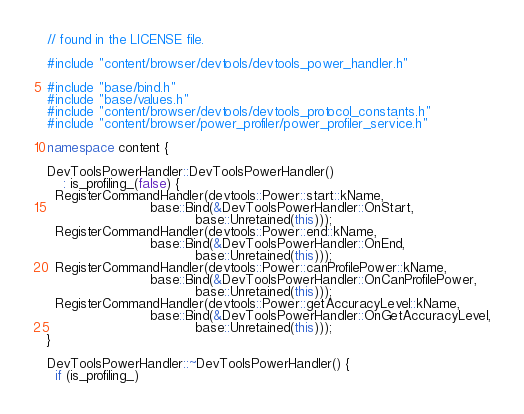<code> <loc_0><loc_0><loc_500><loc_500><_C++_>// found in the LICENSE file.

#include "content/browser/devtools/devtools_power_handler.h"

#include "base/bind.h"
#include "base/values.h"
#include "content/browser/devtools/devtools_protocol_constants.h"
#include "content/browser/power_profiler/power_profiler_service.h"

namespace content {

DevToolsPowerHandler::DevToolsPowerHandler()
    : is_profiling_(false) {
  RegisterCommandHandler(devtools::Power::start::kName,
                         base::Bind(&DevToolsPowerHandler::OnStart,
                                    base::Unretained(this)));
  RegisterCommandHandler(devtools::Power::end::kName,
                         base::Bind(&DevToolsPowerHandler::OnEnd,
                                    base::Unretained(this)));
  RegisterCommandHandler(devtools::Power::canProfilePower::kName,
                         base::Bind(&DevToolsPowerHandler::OnCanProfilePower,
                                    base::Unretained(this)));
  RegisterCommandHandler(devtools::Power::getAccuracyLevel::kName,
                         base::Bind(&DevToolsPowerHandler::OnGetAccuracyLevel,
                                    base::Unretained(this)));
}

DevToolsPowerHandler::~DevToolsPowerHandler() {
  if (is_profiling_)</code> 